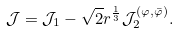Convert formula to latex. <formula><loc_0><loc_0><loc_500><loc_500>\mathcal { J } = \mathcal { J } _ { 1 } - \sqrt { 2 } r ^ { \frac { 1 } { 3 } } \mathcal { J } _ { 2 } ^ { \left ( \varphi , \bar { \varphi } \right ) } .</formula> 